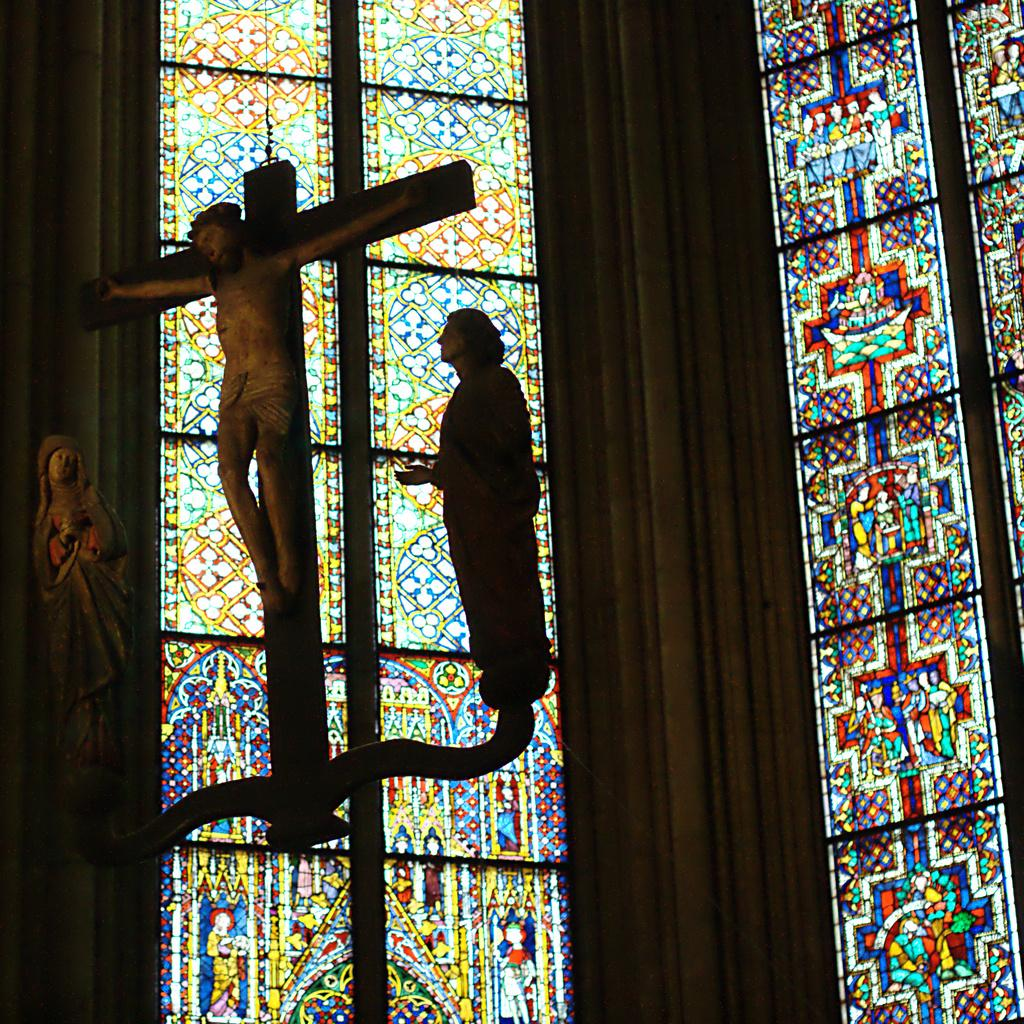How many statues are present in the image? There are three statues of persons in the image. Can you describe the statues in the image? Unfortunately, the provided facts do not give any details about the appearance or characteristics of the statues. What can be seen in the background of the image? There is a glass with a design in the background of the image. What type of field is visible in the image? There is no field present in the image; it features three statues and a glass with a design in the background. How does the glass feel shame in the image? The glass does not feel shame in the image, as it is an inanimate object and cannot experience emotions. 